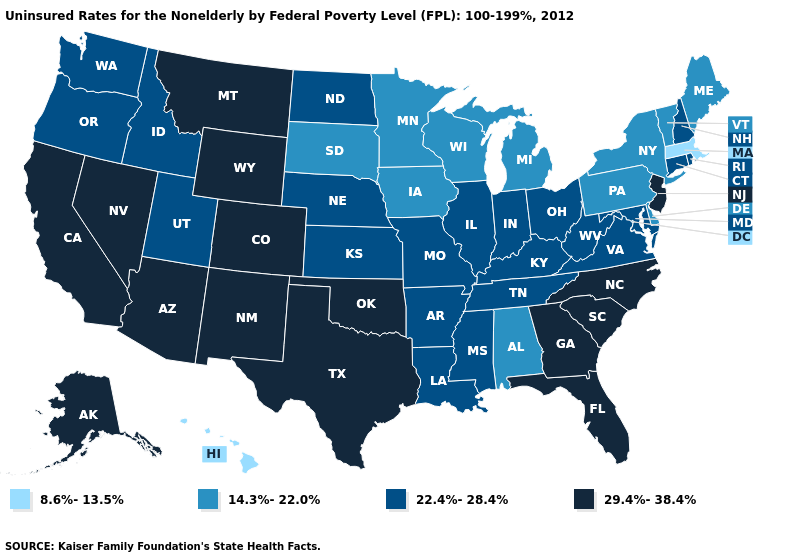Does Arkansas have a lower value than Texas?
Write a very short answer. Yes. Does the map have missing data?
Short answer required. No. Does Alabama have the lowest value in the South?
Short answer required. Yes. Name the states that have a value in the range 29.4%-38.4%?
Answer briefly. Alaska, Arizona, California, Colorado, Florida, Georgia, Montana, Nevada, New Jersey, New Mexico, North Carolina, Oklahoma, South Carolina, Texas, Wyoming. Among the states that border Minnesota , which have the highest value?
Give a very brief answer. North Dakota. What is the value of Massachusetts?
Short answer required. 8.6%-13.5%. Name the states that have a value in the range 29.4%-38.4%?
Short answer required. Alaska, Arizona, California, Colorado, Florida, Georgia, Montana, Nevada, New Jersey, New Mexico, North Carolina, Oklahoma, South Carolina, Texas, Wyoming. What is the value of Texas?
Concise answer only. 29.4%-38.4%. What is the highest value in the West ?
Answer briefly. 29.4%-38.4%. Which states have the lowest value in the USA?
Short answer required. Hawaii, Massachusetts. How many symbols are there in the legend?
Write a very short answer. 4. Which states hav the highest value in the South?
Keep it brief. Florida, Georgia, North Carolina, Oklahoma, South Carolina, Texas. Does the map have missing data?
Give a very brief answer. No. Name the states that have a value in the range 29.4%-38.4%?
Short answer required. Alaska, Arizona, California, Colorado, Florida, Georgia, Montana, Nevada, New Jersey, New Mexico, North Carolina, Oklahoma, South Carolina, Texas, Wyoming. What is the value of California?
Be succinct. 29.4%-38.4%. 